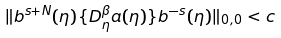Convert formula to latex. <formula><loc_0><loc_0><loc_500><loc_500>\| b ^ { s + N } ( \eta ) \{ D _ { \eta } ^ { \beta } a ( \eta ) \} b ^ { - s } ( \eta ) \| _ { 0 , 0 } < c</formula> 